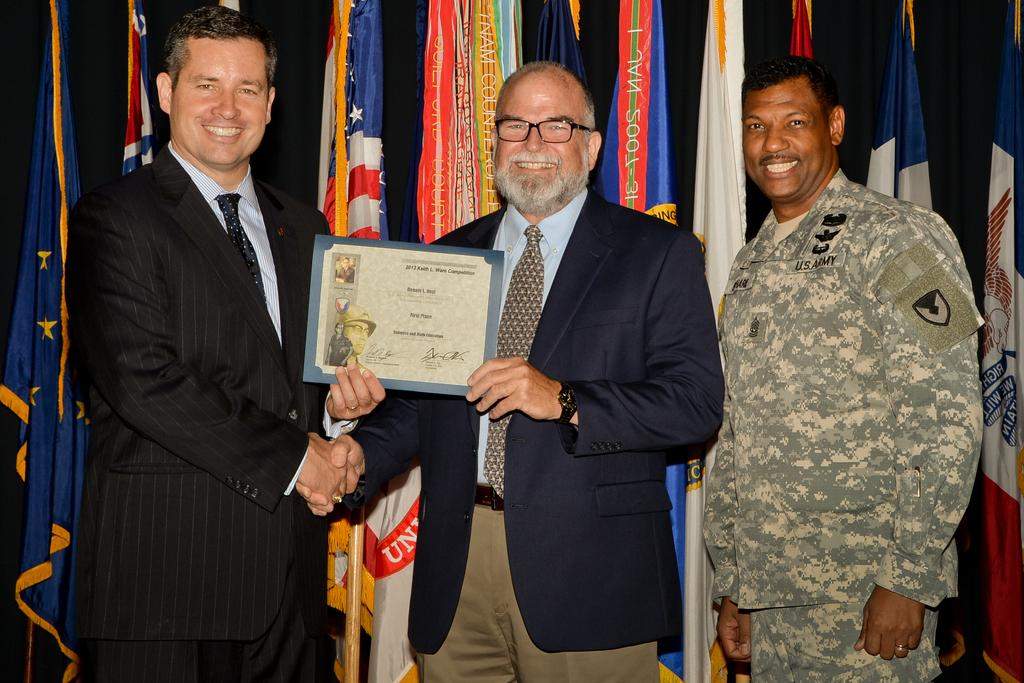How many people are in the image? There are three people standing in the center of the image. What are two of the people holding? Two of the people are holding a book. What can be seen in the background of the image? There are different types of flags and a curtain in the background of the image. What type of collar is the queen wearing in the image? There is no queen present in the image, and therefore no collar can be observed. 